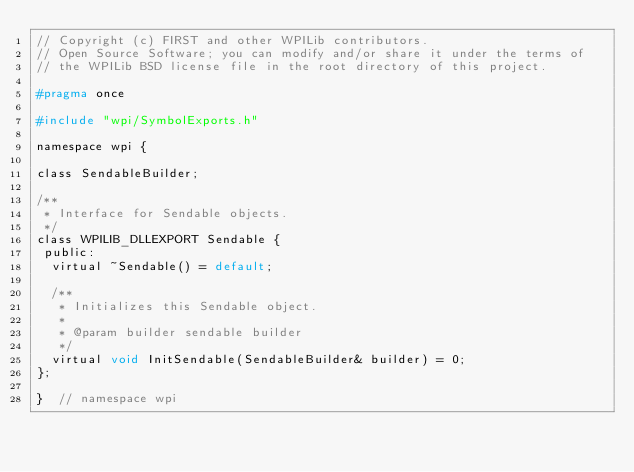<code> <loc_0><loc_0><loc_500><loc_500><_C_>// Copyright (c) FIRST and other WPILib contributors.
// Open Source Software; you can modify and/or share it under the terms of
// the WPILib BSD license file in the root directory of this project.

#pragma once

#include "wpi/SymbolExports.h"

namespace wpi {

class SendableBuilder;

/**
 * Interface for Sendable objects.
 */
class WPILIB_DLLEXPORT Sendable {
 public:
  virtual ~Sendable() = default;

  /**
   * Initializes this Sendable object.
   *
   * @param builder sendable builder
   */
  virtual void InitSendable(SendableBuilder& builder) = 0;
};

}  // namespace wpi
</code> 